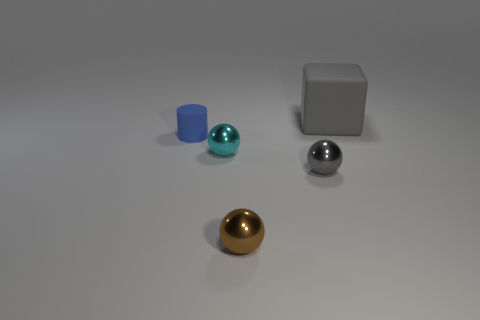Add 2 large gray objects. How many objects exist? 7 Subtract all cubes. How many objects are left? 4 Subtract all red cylinders. Subtract all small rubber objects. How many objects are left? 4 Add 2 big gray matte things. How many big gray matte things are left? 3 Add 5 rubber cubes. How many rubber cubes exist? 6 Subtract 0 cyan cubes. How many objects are left? 5 